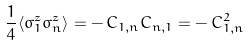Convert formula to latex. <formula><loc_0><loc_0><loc_500><loc_500>\frac { 1 } { 4 } \langle \sigma ^ { z } _ { 1 } \sigma ^ { z } _ { n } \rangle = - \, C _ { 1 , n } C _ { n , 1 } = - \, C _ { 1 , n } ^ { 2 }</formula> 